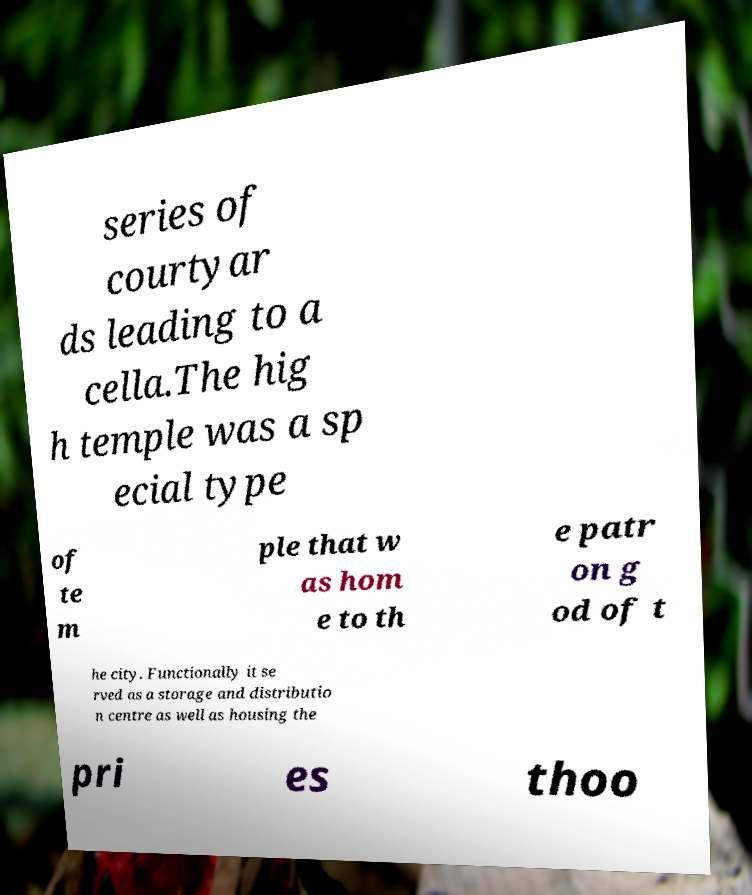Please read and relay the text visible in this image. What does it say? series of courtyar ds leading to a cella.The hig h temple was a sp ecial type of te m ple that w as hom e to th e patr on g od of t he city. Functionally it se rved as a storage and distributio n centre as well as housing the pri es thoo 